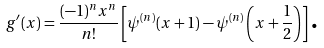Convert formula to latex. <formula><loc_0><loc_0><loc_500><loc_500>g ^ { \prime } ( x ) = \frac { ( - 1 ) ^ { n } x ^ { n } } { n ! } \left [ \psi ^ { ( n ) } ( x + 1 ) - \psi ^ { ( n ) } \left ( x + \frac { 1 } { 2 } \right ) \right ] \text {.}</formula> 